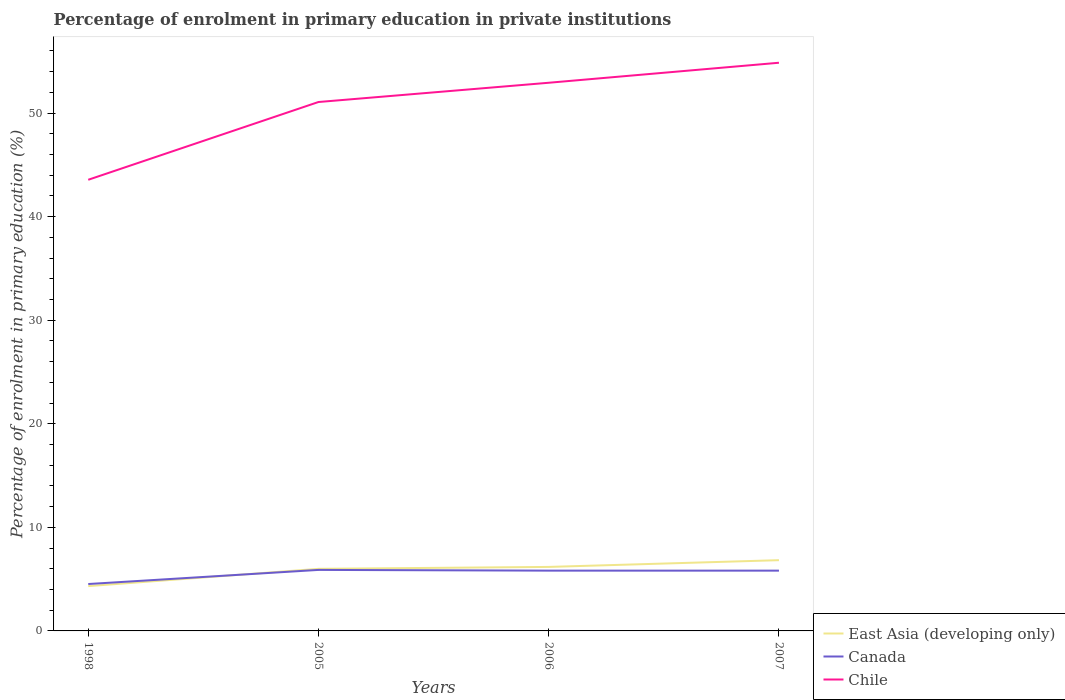Does the line corresponding to East Asia (developing only) intersect with the line corresponding to Canada?
Provide a short and direct response. Yes. Across all years, what is the maximum percentage of enrolment in primary education in East Asia (developing only)?
Provide a short and direct response. 4.33. What is the total percentage of enrolment in primary education in Chile in the graph?
Your response must be concise. -7.51. What is the difference between the highest and the second highest percentage of enrolment in primary education in Canada?
Give a very brief answer. 1.36. Is the percentage of enrolment in primary education in East Asia (developing only) strictly greater than the percentage of enrolment in primary education in Canada over the years?
Offer a terse response. No. How many years are there in the graph?
Your answer should be compact. 4. Are the values on the major ticks of Y-axis written in scientific E-notation?
Provide a short and direct response. No. Does the graph contain any zero values?
Keep it short and to the point. No. Does the graph contain grids?
Ensure brevity in your answer.  No. Where does the legend appear in the graph?
Provide a short and direct response. Bottom right. What is the title of the graph?
Ensure brevity in your answer.  Percentage of enrolment in primary education in private institutions. What is the label or title of the Y-axis?
Provide a succinct answer. Percentage of enrolment in primary education (%). What is the Percentage of enrolment in primary education (%) in East Asia (developing only) in 1998?
Give a very brief answer. 4.33. What is the Percentage of enrolment in primary education (%) of Canada in 1998?
Keep it short and to the point. 4.53. What is the Percentage of enrolment in primary education (%) in Chile in 1998?
Your response must be concise. 43.56. What is the Percentage of enrolment in primary education (%) in East Asia (developing only) in 2005?
Your response must be concise. 6. What is the Percentage of enrolment in primary education (%) of Canada in 2005?
Provide a succinct answer. 5.89. What is the Percentage of enrolment in primary education (%) in Chile in 2005?
Keep it short and to the point. 51.07. What is the Percentage of enrolment in primary education (%) in East Asia (developing only) in 2006?
Provide a short and direct response. 6.18. What is the Percentage of enrolment in primary education (%) of Canada in 2006?
Offer a very short reply. 5.82. What is the Percentage of enrolment in primary education (%) of Chile in 2006?
Offer a terse response. 52.93. What is the Percentage of enrolment in primary education (%) of East Asia (developing only) in 2007?
Offer a terse response. 6.83. What is the Percentage of enrolment in primary education (%) in Canada in 2007?
Provide a short and direct response. 5.82. What is the Percentage of enrolment in primary education (%) of Chile in 2007?
Provide a succinct answer. 54.86. Across all years, what is the maximum Percentage of enrolment in primary education (%) in East Asia (developing only)?
Offer a very short reply. 6.83. Across all years, what is the maximum Percentage of enrolment in primary education (%) of Canada?
Ensure brevity in your answer.  5.89. Across all years, what is the maximum Percentage of enrolment in primary education (%) in Chile?
Keep it short and to the point. 54.86. Across all years, what is the minimum Percentage of enrolment in primary education (%) of East Asia (developing only)?
Your response must be concise. 4.33. Across all years, what is the minimum Percentage of enrolment in primary education (%) of Canada?
Provide a short and direct response. 4.53. Across all years, what is the minimum Percentage of enrolment in primary education (%) in Chile?
Keep it short and to the point. 43.56. What is the total Percentage of enrolment in primary education (%) in East Asia (developing only) in the graph?
Provide a short and direct response. 23.33. What is the total Percentage of enrolment in primary education (%) of Canada in the graph?
Offer a terse response. 22.06. What is the total Percentage of enrolment in primary education (%) in Chile in the graph?
Provide a succinct answer. 202.42. What is the difference between the Percentage of enrolment in primary education (%) in East Asia (developing only) in 1998 and that in 2005?
Your answer should be compact. -1.67. What is the difference between the Percentage of enrolment in primary education (%) in Canada in 1998 and that in 2005?
Give a very brief answer. -1.36. What is the difference between the Percentage of enrolment in primary education (%) of Chile in 1998 and that in 2005?
Provide a succinct answer. -7.51. What is the difference between the Percentage of enrolment in primary education (%) of East Asia (developing only) in 1998 and that in 2006?
Your answer should be compact. -1.85. What is the difference between the Percentage of enrolment in primary education (%) of Canada in 1998 and that in 2006?
Ensure brevity in your answer.  -1.29. What is the difference between the Percentage of enrolment in primary education (%) of Chile in 1998 and that in 2006?
Give a very brief answer. -9.37. What is the difference between the Percentage of enrolment in primary education (%) of East Asia (developing only) in 1998 and that in 2007?
Provide a succinct answer. -2.5. What is the difference between the Percentage of enrolment in primary education (%) of Canada in 1998 and that in 2007?
Provide a succinct answer. -1.29. What is the difference between the Percentage of enrolment in primary education (%) of Chile in 1998 and that in 2007?
Ensure brevity in your answer.  -11.3. What is the difference between the Percentage of enrolment in primary education (%) in East Asia (developing only) in 2005 and that in 2006?
Your answer should be compact. -0.18. What is the difference between the Percentage of enrolment in primary education (%) of Canada in 2005 and that in 2006?
Your response must be concise. 0.07. What is the difference between the Percentage of enrolment in primary education (%) of Chile in 2005 and that in 2006?
Offer a very short reply. -1.86. What is the difference between the Percentage of enrolment in primary education (%) in East Asia (developing only) in 2005 and that in 2007?
Your response must be concise. -0.84. What is the difference between the Percentage of enrolment in primary education (%) in Canada in 2005 and that in 2007?
Keep it short and to the point. 0.07. What is the difference between the Percentage of enrolment in primary education (%) of Chile in 2005 and that in 2007?
Provide a succinct answer. -3.79. What is the difference between the Percentage of enrolment in primary education (%) of East Asia (developing only) in 2006 and that in 2007?
Your response must be concise. -0.65. What is the difference between the Percentage of enrolment in primary education (%) of Canada in 2006 and that in 2007?
Offer a very short reply. 0. What is the difference between the Percentage of enrolment in primary education (%) of Chile in 2006 and that in 2007?
Your response must be concise. -1.93. What is the difference between the Percentage of enrolment in primary education (%) in East Asia (developing only) in 1998 and the Percentage of enrolment in primary education (%) in Canada in 2005?
Make the answer very short. -1.56. What is the difference between the Percentage of enrolment in primary education (%) in East Asia (developing only) in 1998 and the Percentage of enrolment in primary education (%) in Chile in 2005?
Make the answer very short. -46.74. What is the difference between the Percentage of enrolment in primary education (%) in Canada in 1998 and the Percentage of enrolment in primary education (%) in Chile in 2005?
Offer a very short reply. -46.54. What is the difference between the Percentage of enrolment in primary education (%) of East Asia (developing only) in 1998 and the Percentage of enrolment in primary education (%) of Canada in 2006?
Provide a short and direct response. -1.49. What is the difference between the Percentage of enrolment in primary education (%) of East Asia (developing only) in 1998 and the Percentage of enrolment in primary education (%) of Chile in 2006?
Provide a short and direct response. -48.6. What is the difference between the Percentage of enrolment in primary education (%) of Canada in 1998 and the Percentage of enrolment in primary education (%) of Chile in 2006?
Provide a succinct answer. -48.4. What is the difference between the Percentage of enrolment in primary education (%) of East Asia (developing only) in 1998 and the Percentage of enrolment in primary education (%) of Canada in 2007?
Keep it short and to the point. -1.49. What is the difference between the Percentage of enrolment in primary education (%) of East Asia (developing only) in 1998 and the Percentage of enrolment in primary education (%) of Chile in 2007?
Give a very brief answer. -50.53. What is the difference between the Percentage of enrolment in primary education (%) of Canada in 1998 and the Percentage of enrolment in primary education (%) of Chile in 2007?
Keep it short and to the point. -50.33. What is the difference between the Percentage of enrolment in primary education (%) of East Asia (developing only) in 2005 and the Percentage of enrolment in primary education (%) of Canada in 2006?
Make the answer very short. 0.17. What is the difference between the Percentage of enrolment in primary education (%) of East Asia (developing only) in 2005 and the Percentage of enrolment in primary education (%) of Chile in 2006?
Your answer should be very brief. -46.93. What is the difference between the Percentage of enrolment in primary education (%) of Canada in 2005 and the Percentage of enrolment in primary education (%) of Chile in 2006?
Make the answer very short. -47.04. What is the difference between the Percentage of enrolment in primary education (%) in East Asia (developing only) in 2005 and the Percentage of enrolment in primary education (%) in Canada in 2007?
Keep it short and to the point. 0.17. What is the difference between the Percentage of enrolment in primary education (%) of East Asia (developing only) in 2005 and the Percentage of enrolment in primary education (%) of Chile in 2007?
Offer a very short reply. -48.87. What is the difference between the Percentage of enrolment in primary education (%) of Canada in 2005 and the Percentage of enrolment in primary education (%) of Chile in 2007?
Keep it short and to the point. -48.97. What is the difference between the Percentage of enrolment in primary education (%) in East Asia (developing only) in 2006 and the Percentage of enrolment in primary education (%) in Canada in 2007?
Ensure brevity in your answer.  0.36. What is the difference between the Percentage of enrolment in primary education (%) of East Asia (developing only) in 2006 and the Percentage of enrolment in primary education (%) of Chile in 2007?
Keep it short and to the point. -48.68. What is the difference between the Percentage of enrolment in primary education (%) of Canada in 2006 and the Percentage of enrolment in primary education (%) of Chile in 2007?
Keep it short and to the point. -49.04. What is the average Percentage of enrolment in primary education (%) of East Asia (developing only) per year?
Ensure brevity in your answer.  5.83. What is the average Percentage of enrolment in primary education (%) of Canada per year?
Keep it short and to the point. 5.52. What is the average Percentage of enrolment in primary education (%) in Chile per year?
Your answer should be very brief. 50.61. In the year 1998, what is the difference between the Percentage of enrolment in primary education (%) in East Asia (developing only) and Percentage of enrolment in primary education (%) in Canada?
Keep it short and to the point. -0.2. In the year 1998, what is the difference between the Percentage of enrolment in primary education (%) of East Asia (developing only) and Percentage of enrolment in primary education (%) of Chile?
Give a very brief answer. -39.24. In the year 1998, what is the difference between the Percentage of enrolment in primary education (%) of Canada and Percentage of enrolment in primary education (%) of Chile?
Ensure brevity in your answer.  -39.03. In the year 2005, what is the difference between the Percentage of enrolment in primary education (%) of East Asia (developing only) and Percentage of enrolment in primary education (%) of Canada?
Keep it short and to the point. 0.1. In the year 2005, what is the difference between the Percentage of enrolment in primary education (%) of East Asia (developing only) and Percentage of enrolment in primary education (%) of Chile?
Offer a very short reply. -45.08. In the year 2005, what is the difference between the Percentage of enrolment in primary education (%) in Canada and Percentage of enrolment in primary education (%) in Chile?
Give a very brief answer. -45.18. In the year 2006, what is the difference between the Percentage of enrolment in primary education (%) of East Asia (developing only) and Percentage of enrolment in primary education (%) of Canada?
Make the answer very short. 0.36. In the year 2006, what is the difference between the Percentage of enrolment in primary education (%) in East Asia (developing only) and Percentage of enrolment in primary education (%) in Chile?
Give a very brief answer. -46.75. In the year 2006, what is the difference between the Percentage of enrolment in primary education (%) in Canada and Percentage of enrolment in primary education (%) in Chile?
Ensure brevity in your answer.  -47.11. In the year 2007, what is the difference between the Percentage of enrolment in primary education (%) in East Asia (developing only) and Percentage of enrolment in primary education (%) in Chile?
Your response must be concise. -48.03. In the year 2007, what is the difference between the Percentage of enrolment in primary education (%) in Canada and Percentage of enrolment in primary education (%) in Chile?
Give a very brief answer. -49.04. What is the ratio of the Percentage of enrolment in primary education (%) of East Asia (developing only) in 1998 to that in 2005?
Ensure brevity in your answer.  0.72. What is the ratio of the Percentage of enrolment in primary education (%) in Canada in 1998 to that in 2005?
Keep it short and to the point. 0.77. What is the ratio of the Percentage of enrolment in primary education (%) in Chile in 1998 to that in 2005?
Your answer should be compact. 0.85. What is the ratio of the Percentage of enrolment in primary education (%) in East Asia (developing only) in 1998 to that in 2006?
Offer a very short reply. 0.7. What is the ratio of the Percentage of enrolment in primary education (%) in Canada in 1998 to that in 2006?
Offer a very short reply. 0.78. What is the ratio of the Percentage of enrolment in primary education (%) in Chile in 1998 to that in 2006?
Offer a very short reply. 0.82. What is the ratio of the Percentage of enrolment in primary education (%) of East Asia (developing only) in 1998 to that in 2007?
Your answer should be compact. 0.63. What is the ratio of the Percentage of enrolment in primary education (%) of Canada in 1998 to that in 2007?
Offer a terse response. 0.78. What is the ratio of the Percentage of enrolment in primary education (%) in Chile in 1998 to that in 2007?
Your answer should be compact. 0.79. What is the ratio of the Percentage of enrolment in primary education (%) of East Asia (developing only) in 2005 to that in 2006?
Keep it short and to the point. 0.97. What is the ratio of the Percentage of enrolment in primary education (%) of Canada in 2005 to that in 2006?
Make the answer very short. 1.01. What is the ratio of the Percentage of enrolment in primary education (%) in Chile in 2005 to that in 2006?
Offer a terse response. 0.96. What is the ratio of the Percentage of enrolment in primary education (%) in East Asia (developing only) in 2005 to that in 2007?
Ensure brevity in your answer.  0.88. What is the ratio of the Percentage of enrolment in primary education (%) in Canada in 2005 to that in 2007?
Offer a terse response. 1.01. What is the ratio of the Percentage of enrolment in primary education (%) of Chile in 2005 to that in 2007?
Ensure brevity in your answer.  0.93. What is the ratio of the Percentage of enrolment in primary education (%) of East Asia (developing only) in 2006 to that in 2007?
Offer a terse response. 0.9. What is the ratio of the Percentage of enrolment in primary education (%) in Canada in 2006 to that in 2007?
Make the answer very short. 1. What is the ratio of the Percentage of enrolment in primary education (%) of Chile in 2006 to that in 2007?
Your answer should be compact. 0.96. What is the difference between the highest and the second highest Percentage of enrolment in primary education (%) of East Asia (developing only)?
Make the answer very short. 0.65. What is the difference between the highest and the second highest Percentage of enrolment in primary education (%) of Canada?
Provide a succinct answer. 0.07. What is the difference between the highest and the second highest Percentage of enrolment in primary education (%) of Chile?
Provide a short and direct response. 1.93. What is the difference between the highest and the lowest Percentage of enrolment in primary education (%) of East Asia (developing only)?
Your answer should be very brief. 2.5. What is the difference between the highest and the lowest Percentage of enrolment in primary education (%) in Canada?
Ensure brevity in your answer.  1.36. What is the difference between the highest and the lowest Percentage of enrolment in primary education (%) in Chile?
Your answer should be compact. 11.3. 